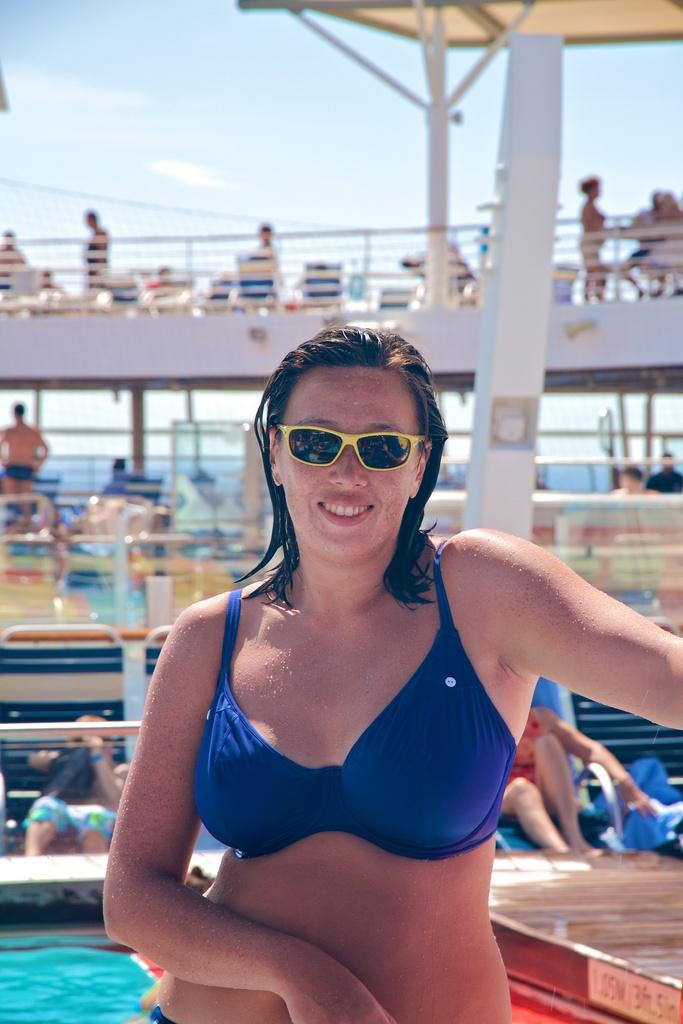Who is present in the image? There is a woman in the image. What is the woman doing in the image? The woman is smiling in the image. Can you describe the group of people in the image? There is a group of people sitting and standing in the image. What else can be seen in the image besides the people? There are objects and water visible in the image. What is visible in the background of the image? The sky is visible in the background of the image. What type of leather is being used to make the orange in the image? There is no leather or orange present in the image. 